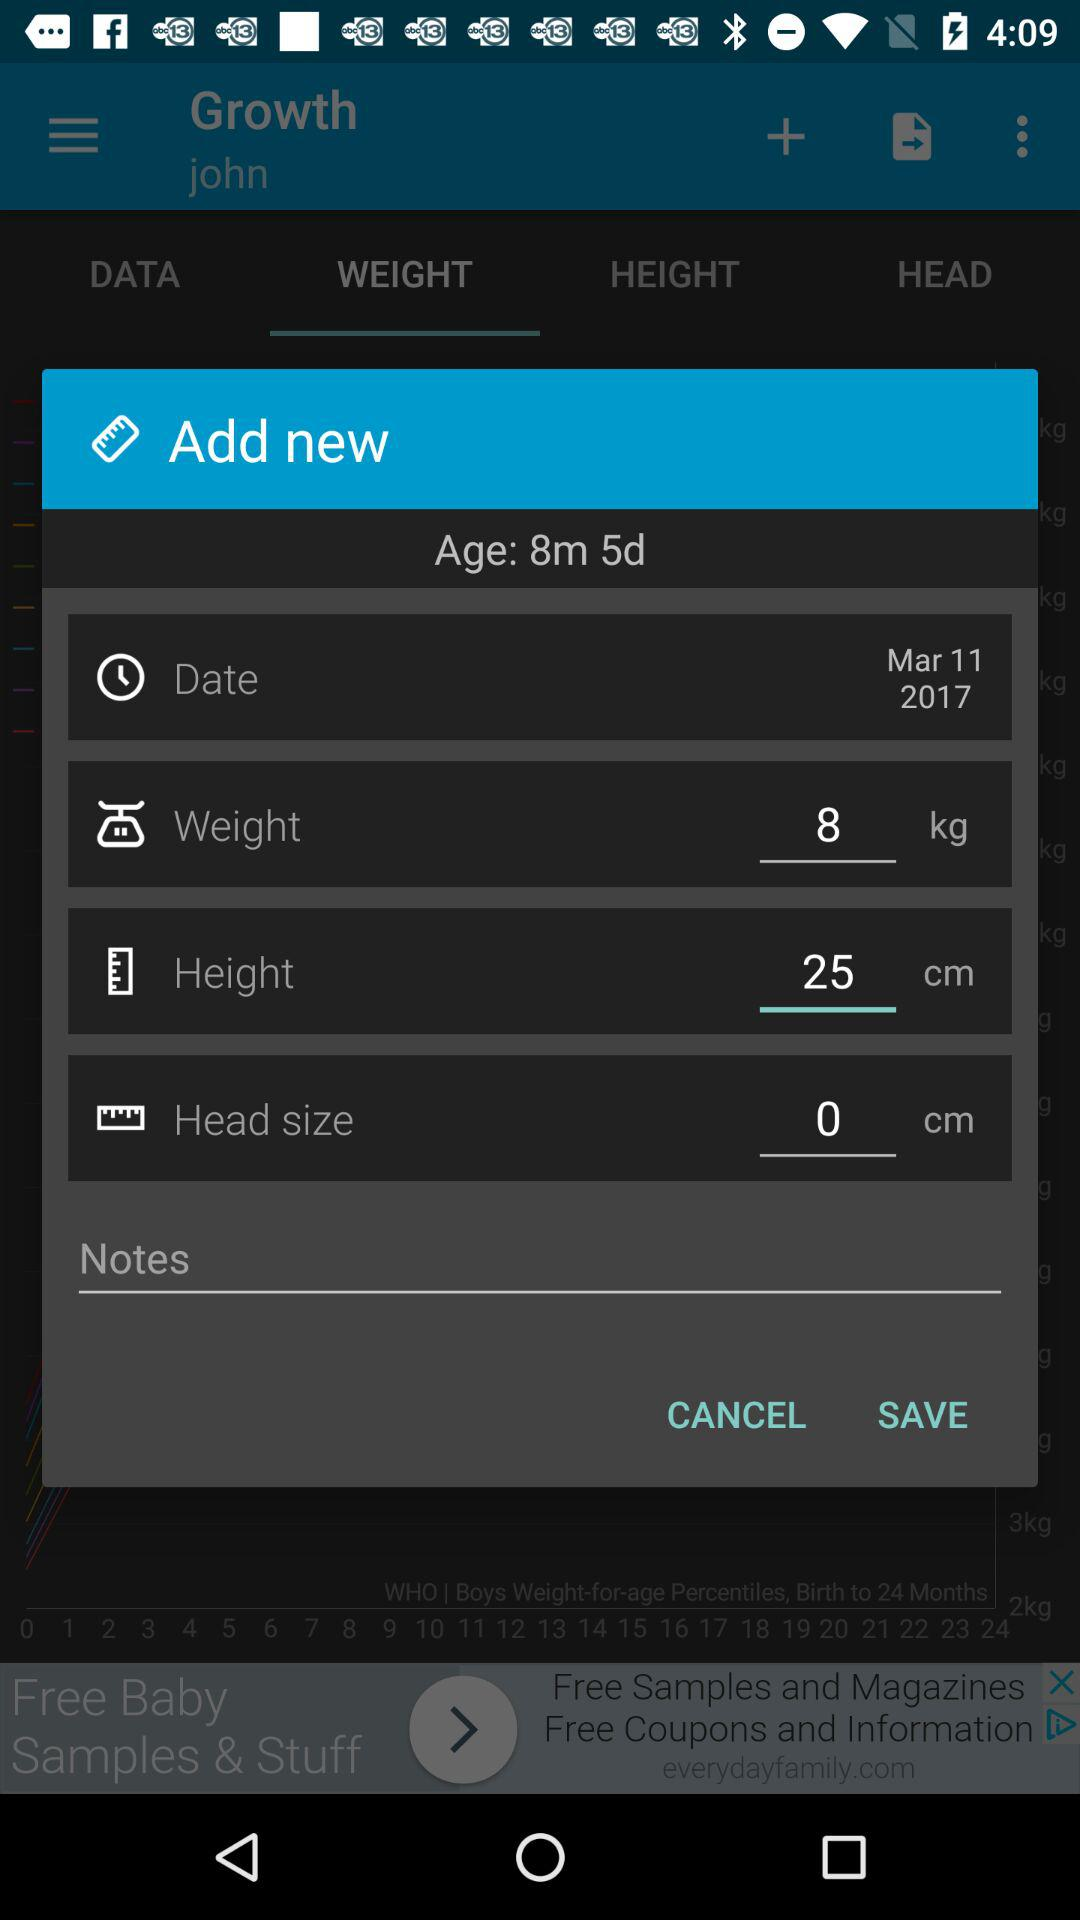Please remind me, what are some of the important growth milestones to watch for in an 8-month-old baby? At 8 months old, important growth milestones to watch for include improved hand-eye coordination, starting to crawl, sitting without support, and possibly beginning to stand with assistance. Babies may also show increased curiosity about their environment, and some might start saying simple syllables like 'ma' or 'da'. 